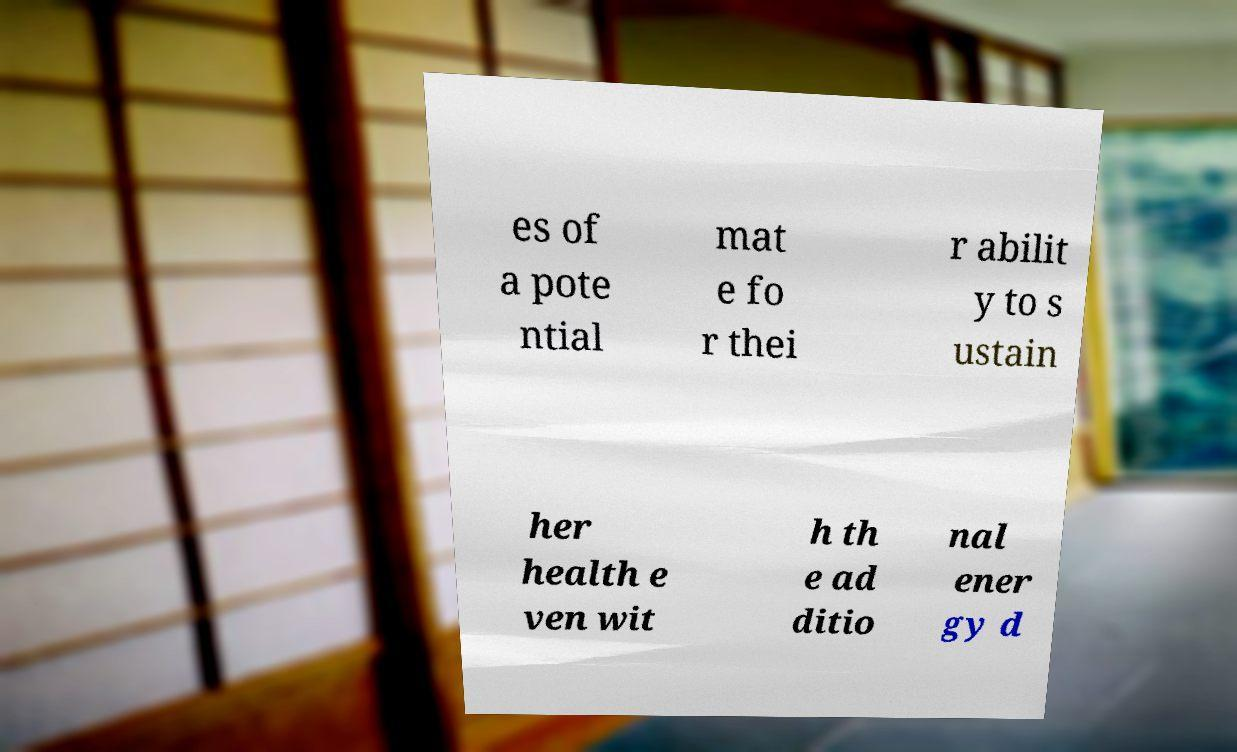What messages or text are displayed in this image? I need them in a readable, typed format. es of a pote ntial mat e fo r thei r abilit y to s ustain her health e ven wit h th e ad ditio nal ener gy d 